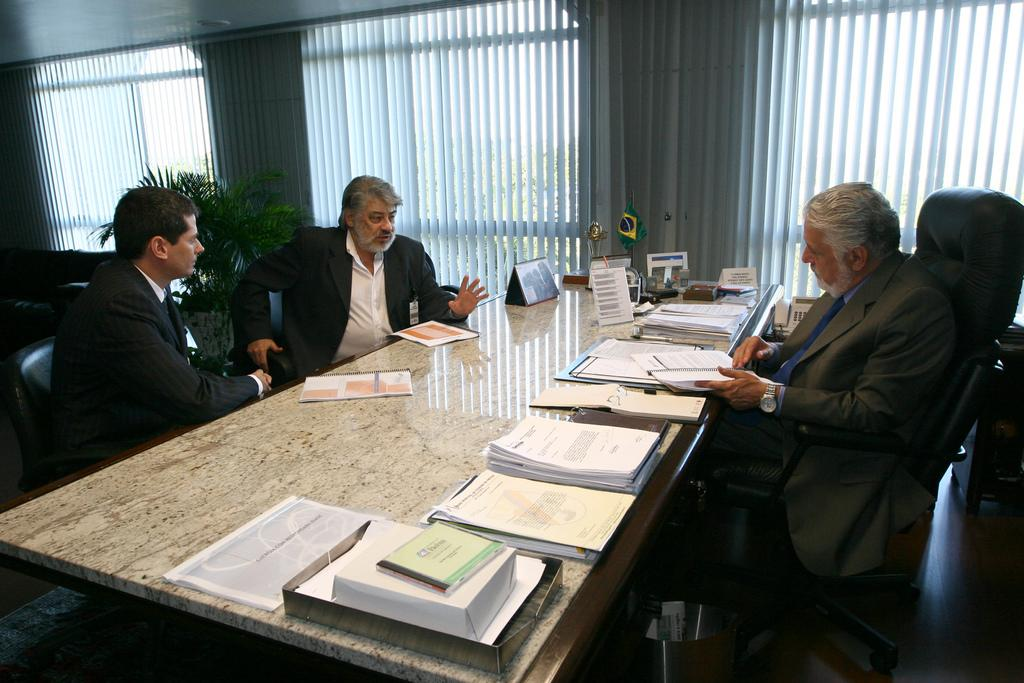How many men are in the image? There are three men in the image. What are the men doing in the image? The men are sitting on chairs. What can be seen on the table in the image? There are papers on a table in the image. What is visible in the background of the image? There is a plant, a window, and a wall in the background of the image. What type of pear is hanging from the chain in the image? There is no pear or chain present in the image. What design is featured on the wall in the image? The provided facts do not mention any specific design on the wall; it is simply described as a wall in the background. 